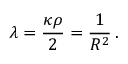Convert formula to latex. <formula><loc_0><loc_0><loc_500><loc_500>\lambda = \frac { \kappa \rho } { 2 } = \frac { 1 } { R ^ { 2 } } \, .</formula> 